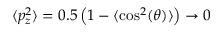Convert formula to latex. <formula><loc_0><loc_0><loc_500><loc_500>\langle p _ { z } ^ { 2 } \rangle = 0 . 5 \left ( 1 - \langle \cos ^ { 2 } ( \theta ) \rangle \right ) \rightarrow 0</formula> 